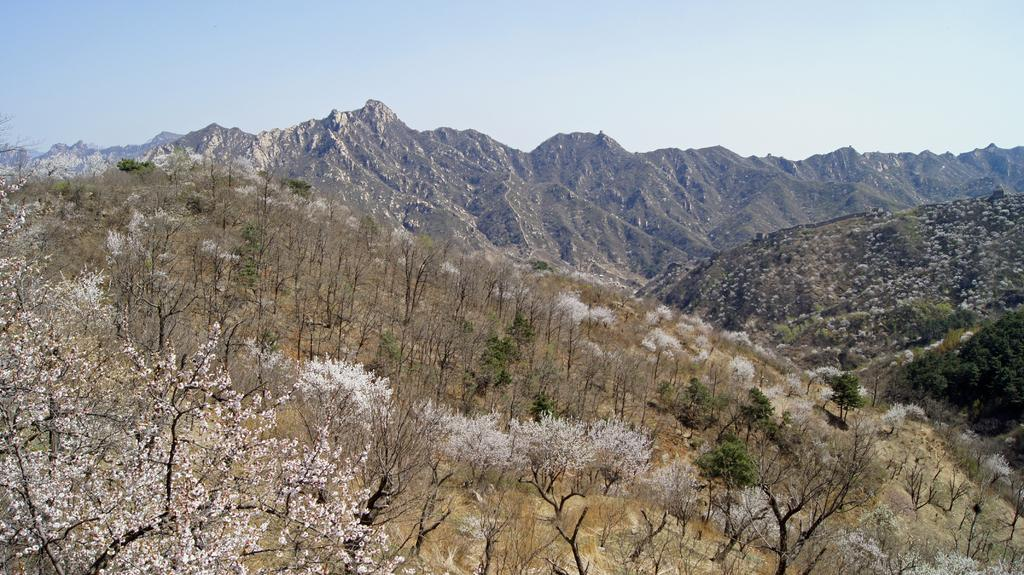What type of vegetation is present in the image? There are grass plants and trees with white flowers in the image. Can you describe the trees in the image? The trees in the image have white flowers. What can be seen in the background of the image? There are hills with rocks visible in the background of the image, along with the sky. What type of potato is being used to create the white flowers on the trees in the image? There are no potatoes present in the image, and the white flowers on the trees are not created by potatoes. 